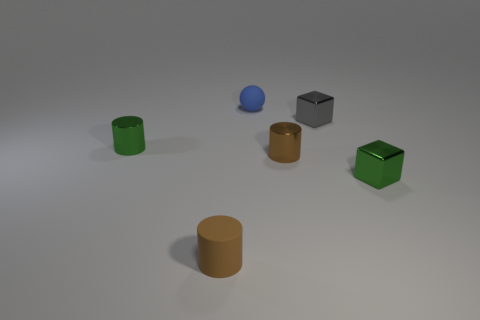What is the shape of the tiny green thing in front of the brown thing behind the tiny cube right of the gray shiny block?
Your response must be concise. Cube. There is a tiny green cylinder behind the tiny rubber thing to the left of the tiny sphere; what is it made of?
Give a very brief answer. Metal. What shape is the brown object that is made of the same material as the gray cube?
Provide a short and direct response. Cylinder. Are there any other things that have the same shape as the blue thing?
Your response must be concise. No. There is a small blue ball; what number of small metal things are on the right side of it?
Your response must be concise. 3. Are any brown metallic things visible?
Provide a succinct answer. Yes. What color is the small cylinder that is behind the small cylinder that is on the right side of the small rubber object behind the gray metal cube?
Provide a succinct answer. Green. Is there a gray thing on the right side of the gray cube that is to the right of the brown matte cylinder?
Provide a succinct answer. No. Does the cube that is in front of the green cylinder have the same color as the metallic cylinder to the left of the ball?
Your answer should be very brief. Yes. What number of shiny cubes are the same size as the brown rubber object?
Your answer should be compact. 2. 